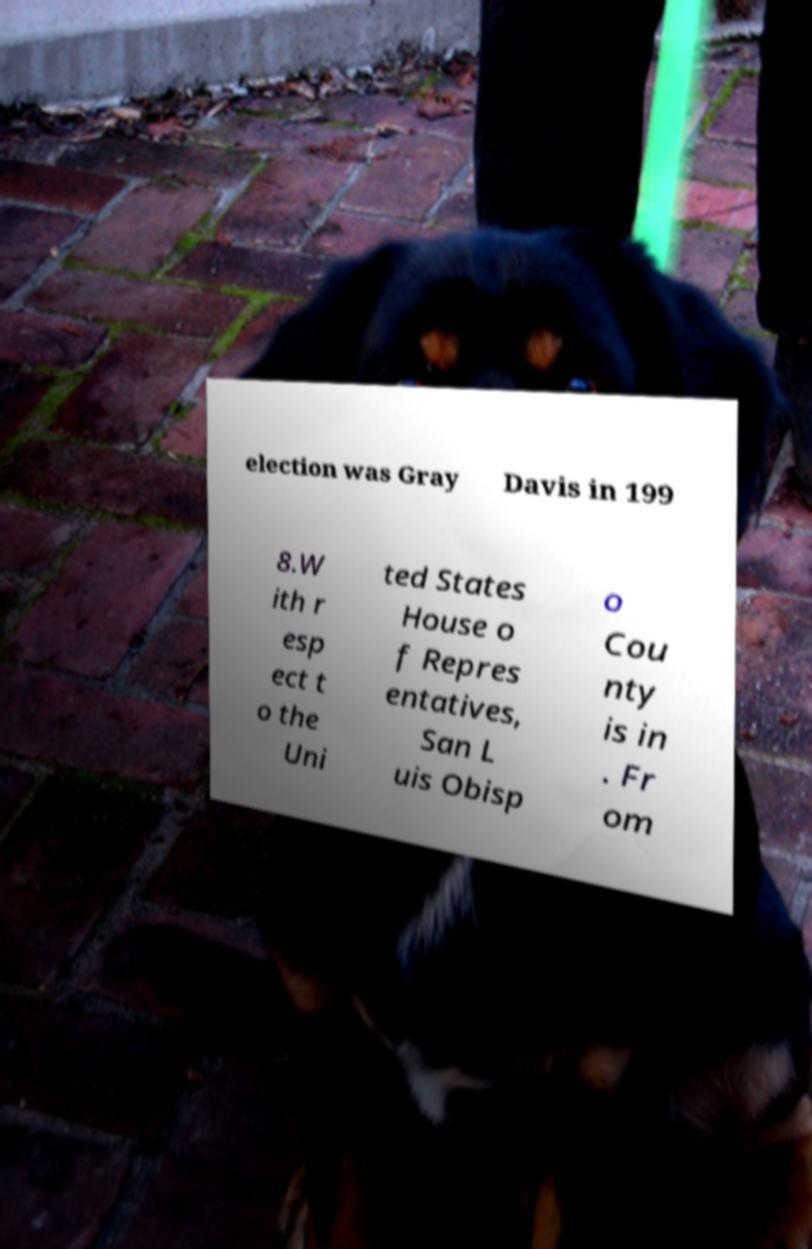What messages or text are displayed in this image? I need them in a readable, typed format. election was Gray Davis in 199 8.W ith r esp ect t o the Uni ted States House o f Repres entatives, San L uis Obisp o Cou nty is in . Fr om 